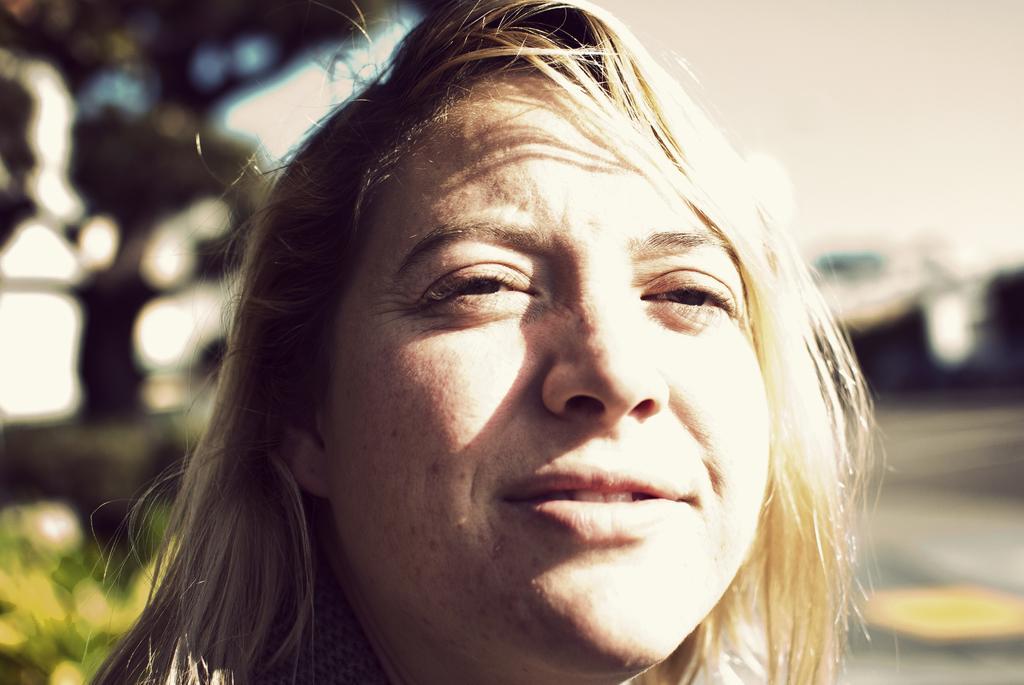Describe this image in one or two sentences. In this image we can see a woman's face. The background is blurry. 